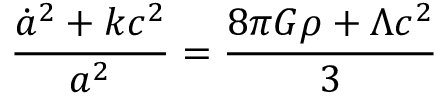<formula> <loc_0><loc_0><loc_500><loc_500>{ \frac { { \dot { a } } ^ { 2 } + k c ^ { 2 } } { a ^ { 2 } } } = { \frac { 8 \pi G \rho + \Lambda c ^ { 2 } } { 3 } }</formula> 